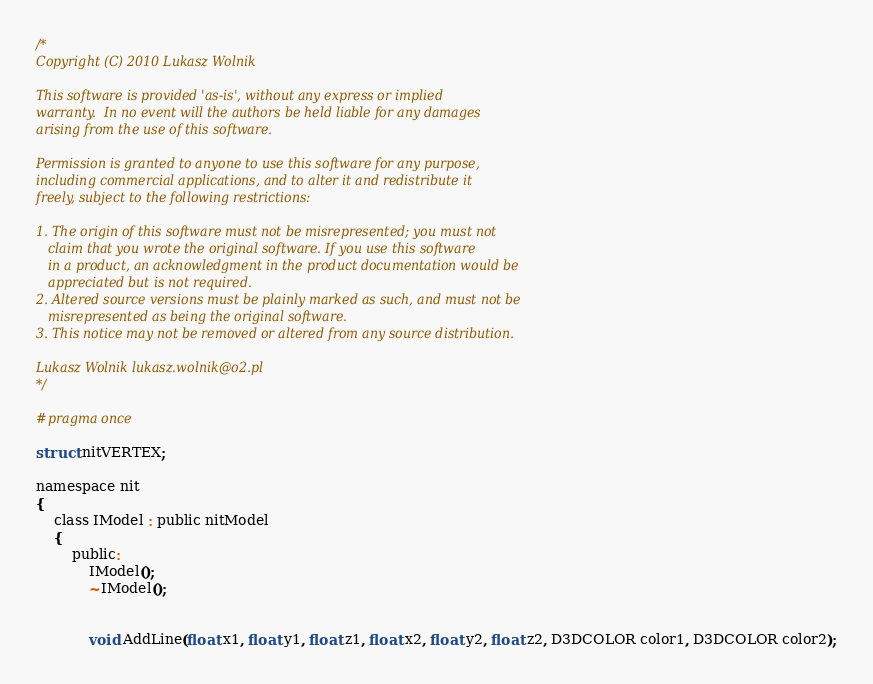Convert code to text. <code><loc_0><loc_0><loc_500><loc_500><_C_>/*
Copyright (C) 2010 Lukasz Wolnik

This software is provided 'as-is', without any express or implied
warranty.  In no event will the authors be held liable for any damages
arising from the use of this software.

Permission is granted to anyone to use this software for any purpose,
including commercial applications, and to alter it and redistribute it
freely, subject to the following restrictions:

1. The origin of this software must not be misrepresented; you must not
   claim that you wrote the original software. If you use this software
   in a product, an acknowledgment in the product documentation would be
   appreciated but is not required.
2. Altered source versions must be plainly marked as such, and must not be
   misrepresented as being the original software.
3. This notice may not be removed or altered from any source distribution.

Lukasz Wolnik lukasz.wolnik@o2.pl
*/

#pragma once

struct nitVERTEX;

namespace nit
{
	class IModel : public nitModel
	{
		public:
			IModel();
			~IModel();

			
			void AddLine(float x1, float y1, float z1, float x2, float y2, float z2, D3DCOLOR color1, D3DCOLOR color2);</code> 